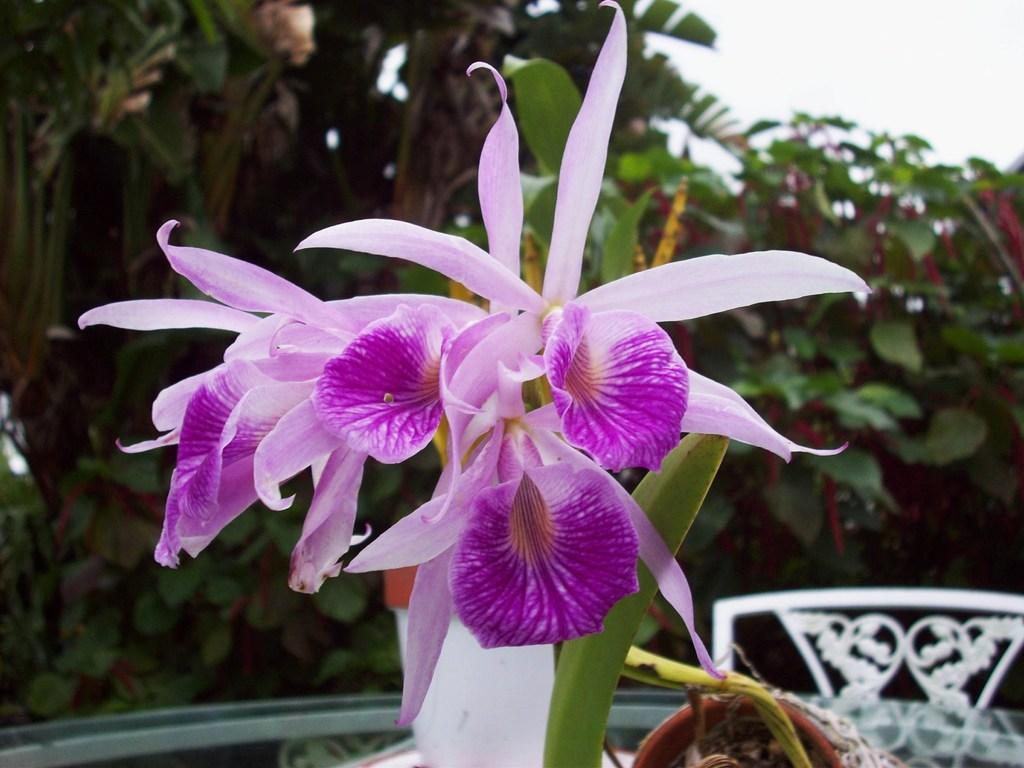What type of plants can be seen in the image? There are flowers in the image. What color are the flowers? The flowers are pink in color. What else can be seen in the image besides the flowers? There are leaves, a table, a chair, trees, and the sky visible in the background of the image. What type of steel is used to construct the secretary's desk in the image? There is no secretary or desk present in the image; it features flowers, leaves, a table, a chair, trees, and the sky. 